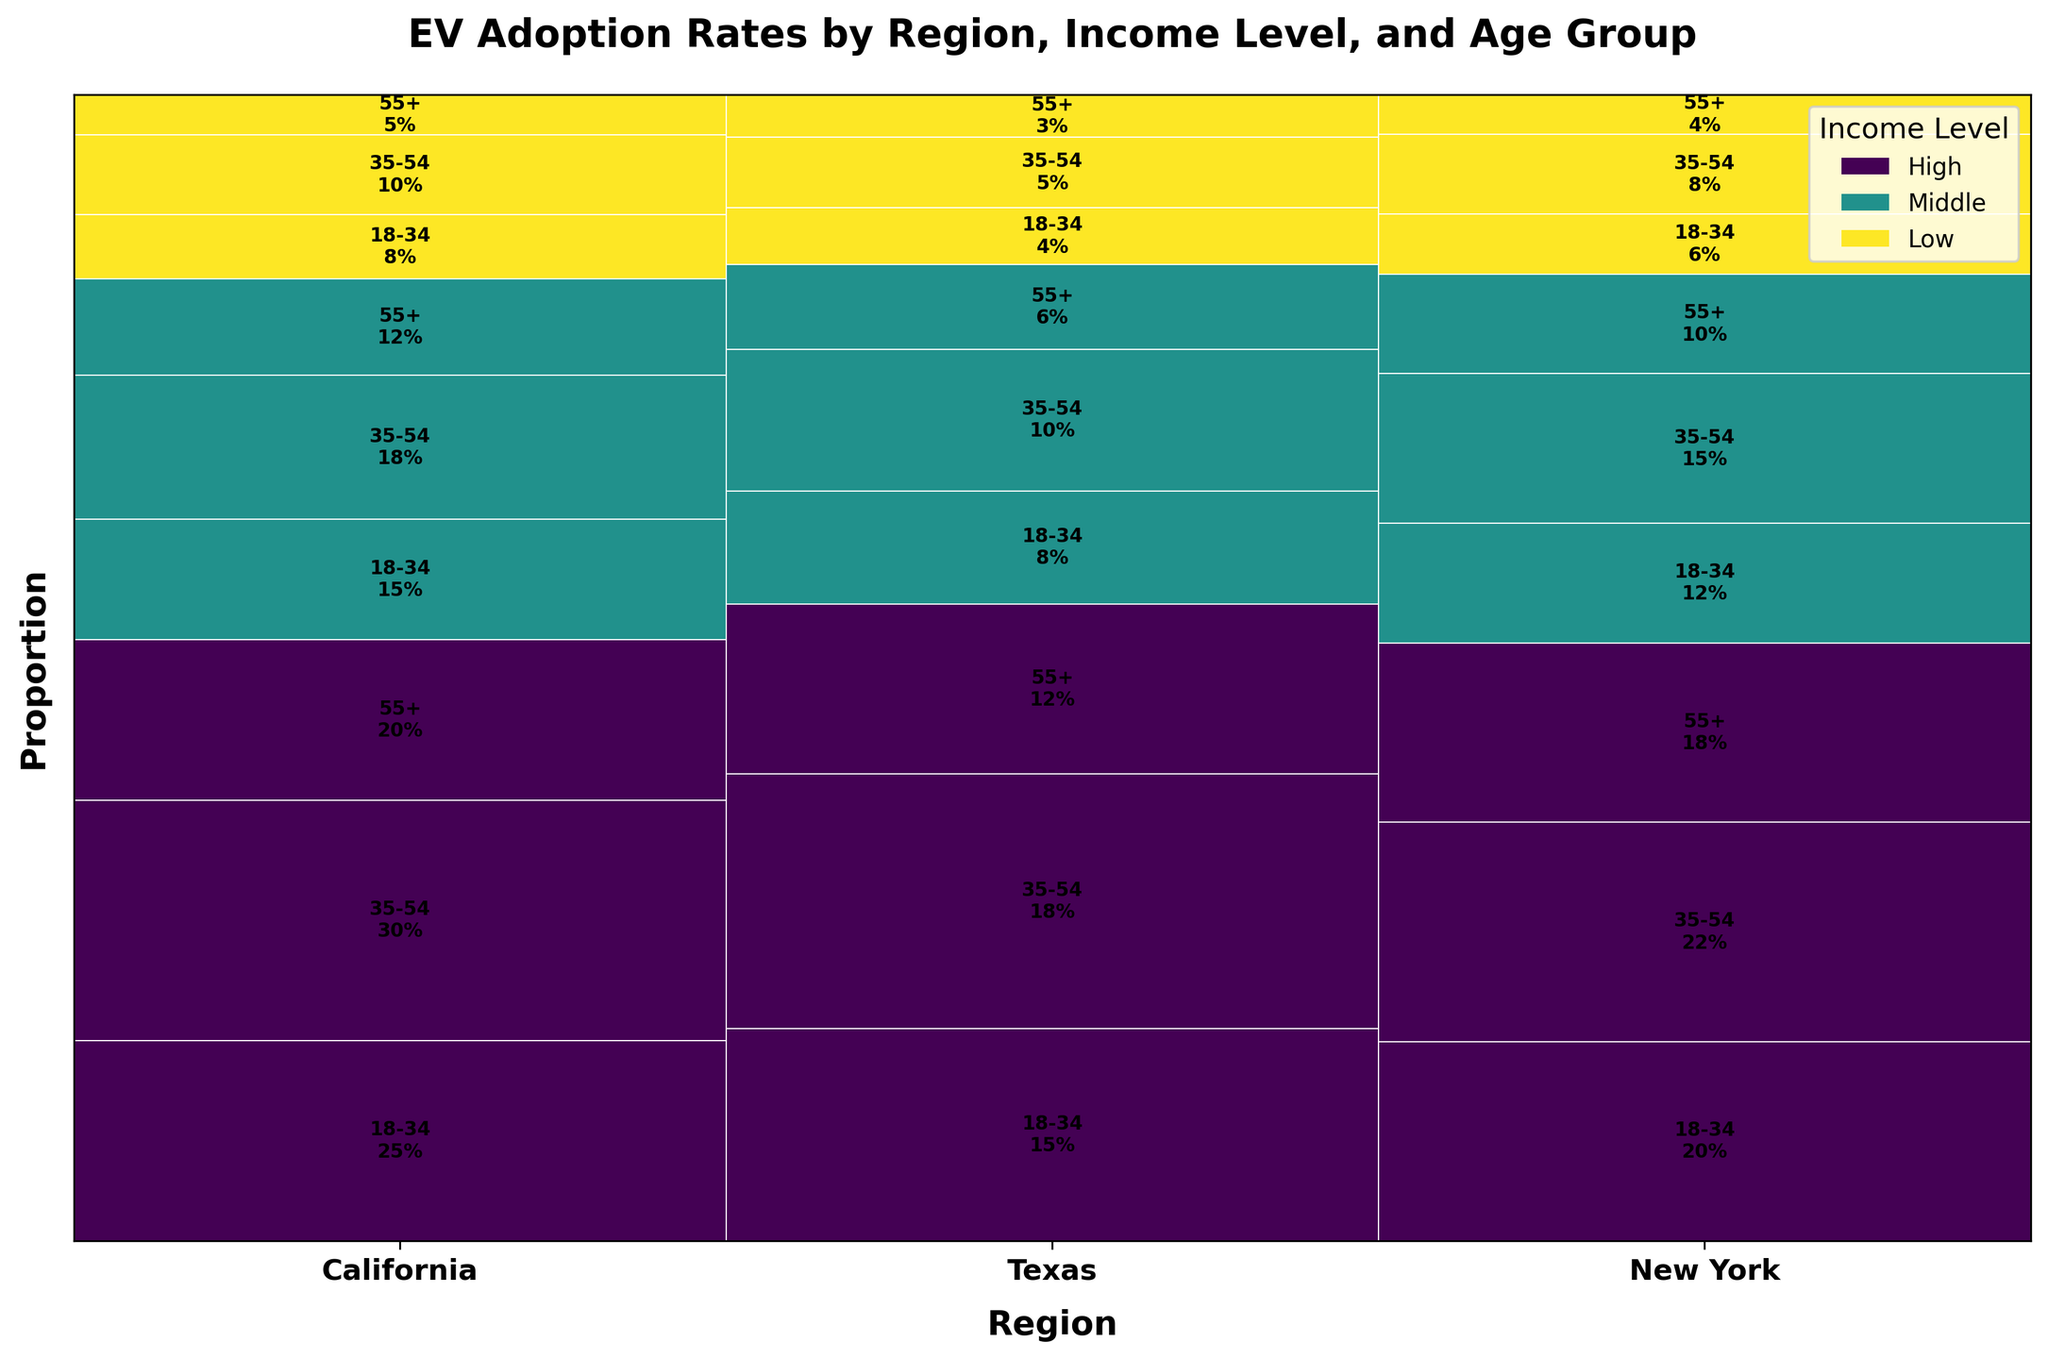What is the EV adoption rate for high-income individuals aged 35-54 in California? Locate California on the x-axis and identify the color representing the high-income group. Find the section for the 35-54 age group and read the adoption rate inside the rectangle.
Answer: 30% Which region has the highest adoption rate for low-income individuals aged 18-34? Compare the EV adoption rates for low-income individuals aged 18-34 across all regions. Identify which region has the largest height for this demographic group in the mosaic plot.
Answer: California What is the total EV adoption rate for middle-income individuals across all age groups in Texas? Locate Texas on the x-axis and sum the EV adoption rates of middle-income individuals across all age groups (8% for 18-34, 10% for 35-54, 6% for 55+).
Answer: 24% Which age group has the lowest EV adoption rate among high-income individuals in New York? For high-income individuals in New York, compare the adoption rates across the age groups (18-34, 35-54, 55+). Identify the age group with the smallest value.
Answer: 55+ Between California and New York, which region has a higher total EV adoption rate for middle-income individuals? Sum the EV adoption rates across all age groups for middle-income individuals in California and New York, then compare the two sums. California: (15 + 18 + 12) = 45%, New York: (12 + 15 + 10) = 37%.
Answer: California What is the proportion of EV adoption rate for low-income individuals aged 55+ in Texas compared to the total EV adoption rate in Texas? Determine the EV adoption rate for low-income individuals aged 55+ in Texas (3%) and divide it by the total EV adoption rate in Texas (63%). Calculate the ratio to find the proportion.
Answer: 4.76% Which income level has the highest average EV adoption rate across all age groups in California? Calculate the average EV adoption rate for each income level in California by summing their values and dividing by the number of age groups. Compare these averages to find the highest. High: (25 + 30 + 20)/3 = 25%, Middle: (15 + 18 + 12)/3 = 15%, Low: (8 + 10 + 5)/3 = 7.67%.
Answer: High What is the difference in EV adoption rate between high-income individuals aged 18-34 in California and Texas? Identify the EV adoption rates for high-income individuals aged 18-34 in both regions (25% in California and 15% in Texas) and calculate the difference between them.
Answer: 10% 